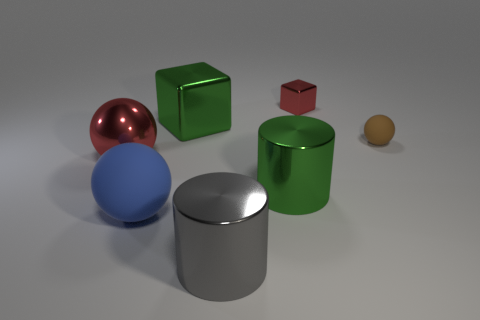There is a object that is made of the same material as the big blue sphere; what is its shape?
Provide a short and direct response. Sphere. There is a matte ball left of the brown object that is right of the big green metallic object in front of the large red metal sphere; what color is it?
Offer a very short reply. Blue. Are there the same number of cubes that are in front of the large shiny block and tiny purple matte objects?
Provide a succinct answer. Yes. Are there any other things that are the same material as the large blue ball?
Provide a short and direct response. Yes. There is a tiny sphere; does it have the same color as the big sphere in front of the large red ball?
Offer a terse response. No. Are there any tiny brown matte spheres that are to the right of the rubber thing on the right side of the red thing on the right side of the large green shiny cylinder?
Offer a terse response. No. Are there fewer green metallic cubes that are to the right of the gray shiny thing than shiny spheres?
Your response must be concise. Yes. What number of other things are the same shape as the small metallic thing?
Provide a short and direct response. 1. How many objects are red metallic objects to the left of the big blue matte ball or big blocks in front of the tiny red metal block?
Provide a succinct answer. 2. What is the size of the shiny thing that is both right of the big gray cylinder and behind the big green cylinder?
Your response must be concise. Small. 